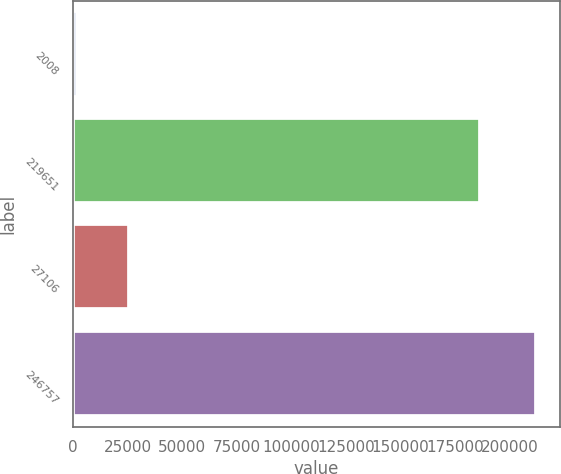Convert chart. <chart><loc_0><loc_0><loc_500><loc_500><bar_chart><fcel>2008<fcel>219651<fcel>27106<fcel>246757<nl><fcel>2007<fcel>186654<fcel>25710<fcel>212364<nl></chart> 